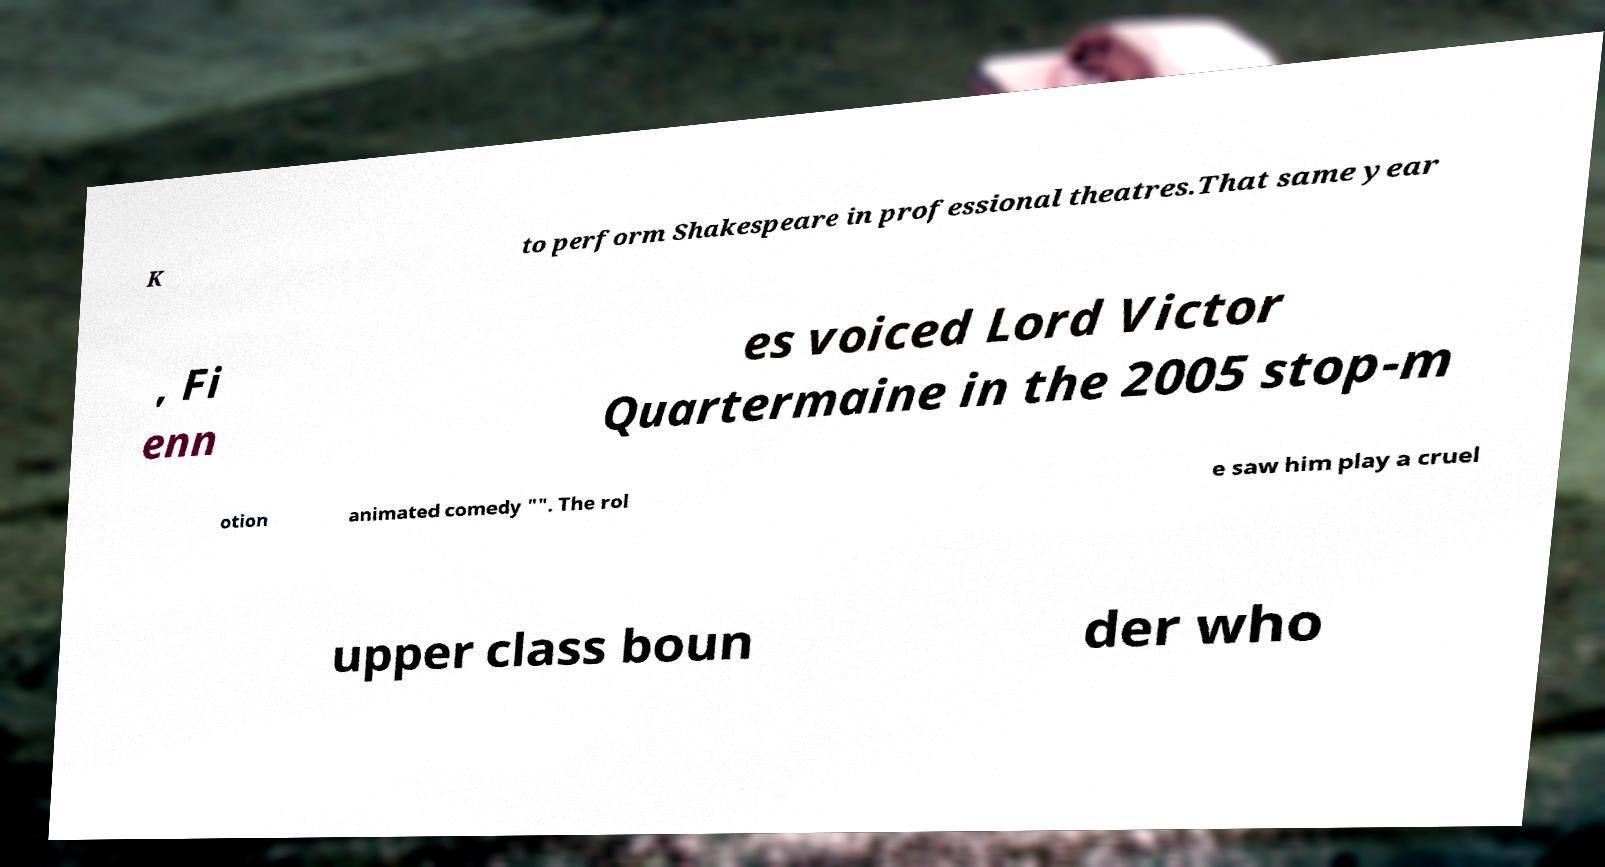Please identify and transcribe the text found in this image. K to perform Shakespeare in professional theatres.That same year , Fi enn es voiced Lord Victor Quartermaine in the 2005 stop-m otion animated comedy "". The rol e saw him play a cruel upper class boun der who 